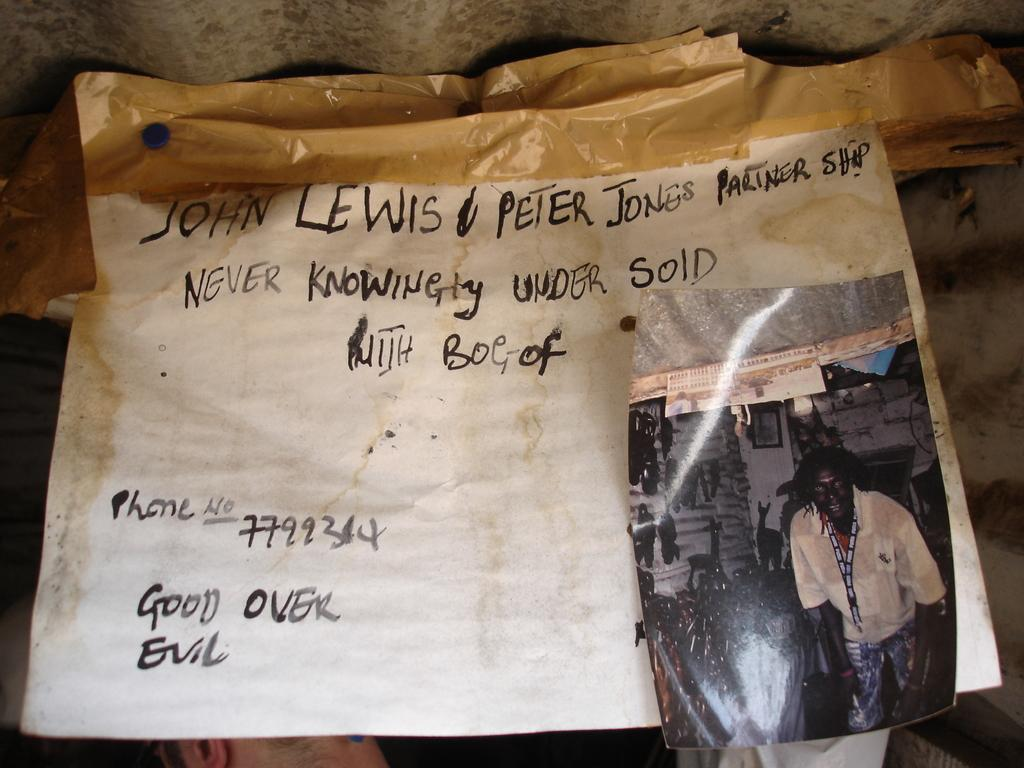What is the main subject in the center of the picture? There is a chart in the center of the picture. What other visual elements can be seen in the picture? There is a photograph in the picture. What objects are located at the top of the picture? There are nails and a sticker at the top of the picture. Can you see the ocean in the picture? No, the ocean is not present in the picture. Is there a prison visible in the picture? No, there is no prison visible in the picture. 